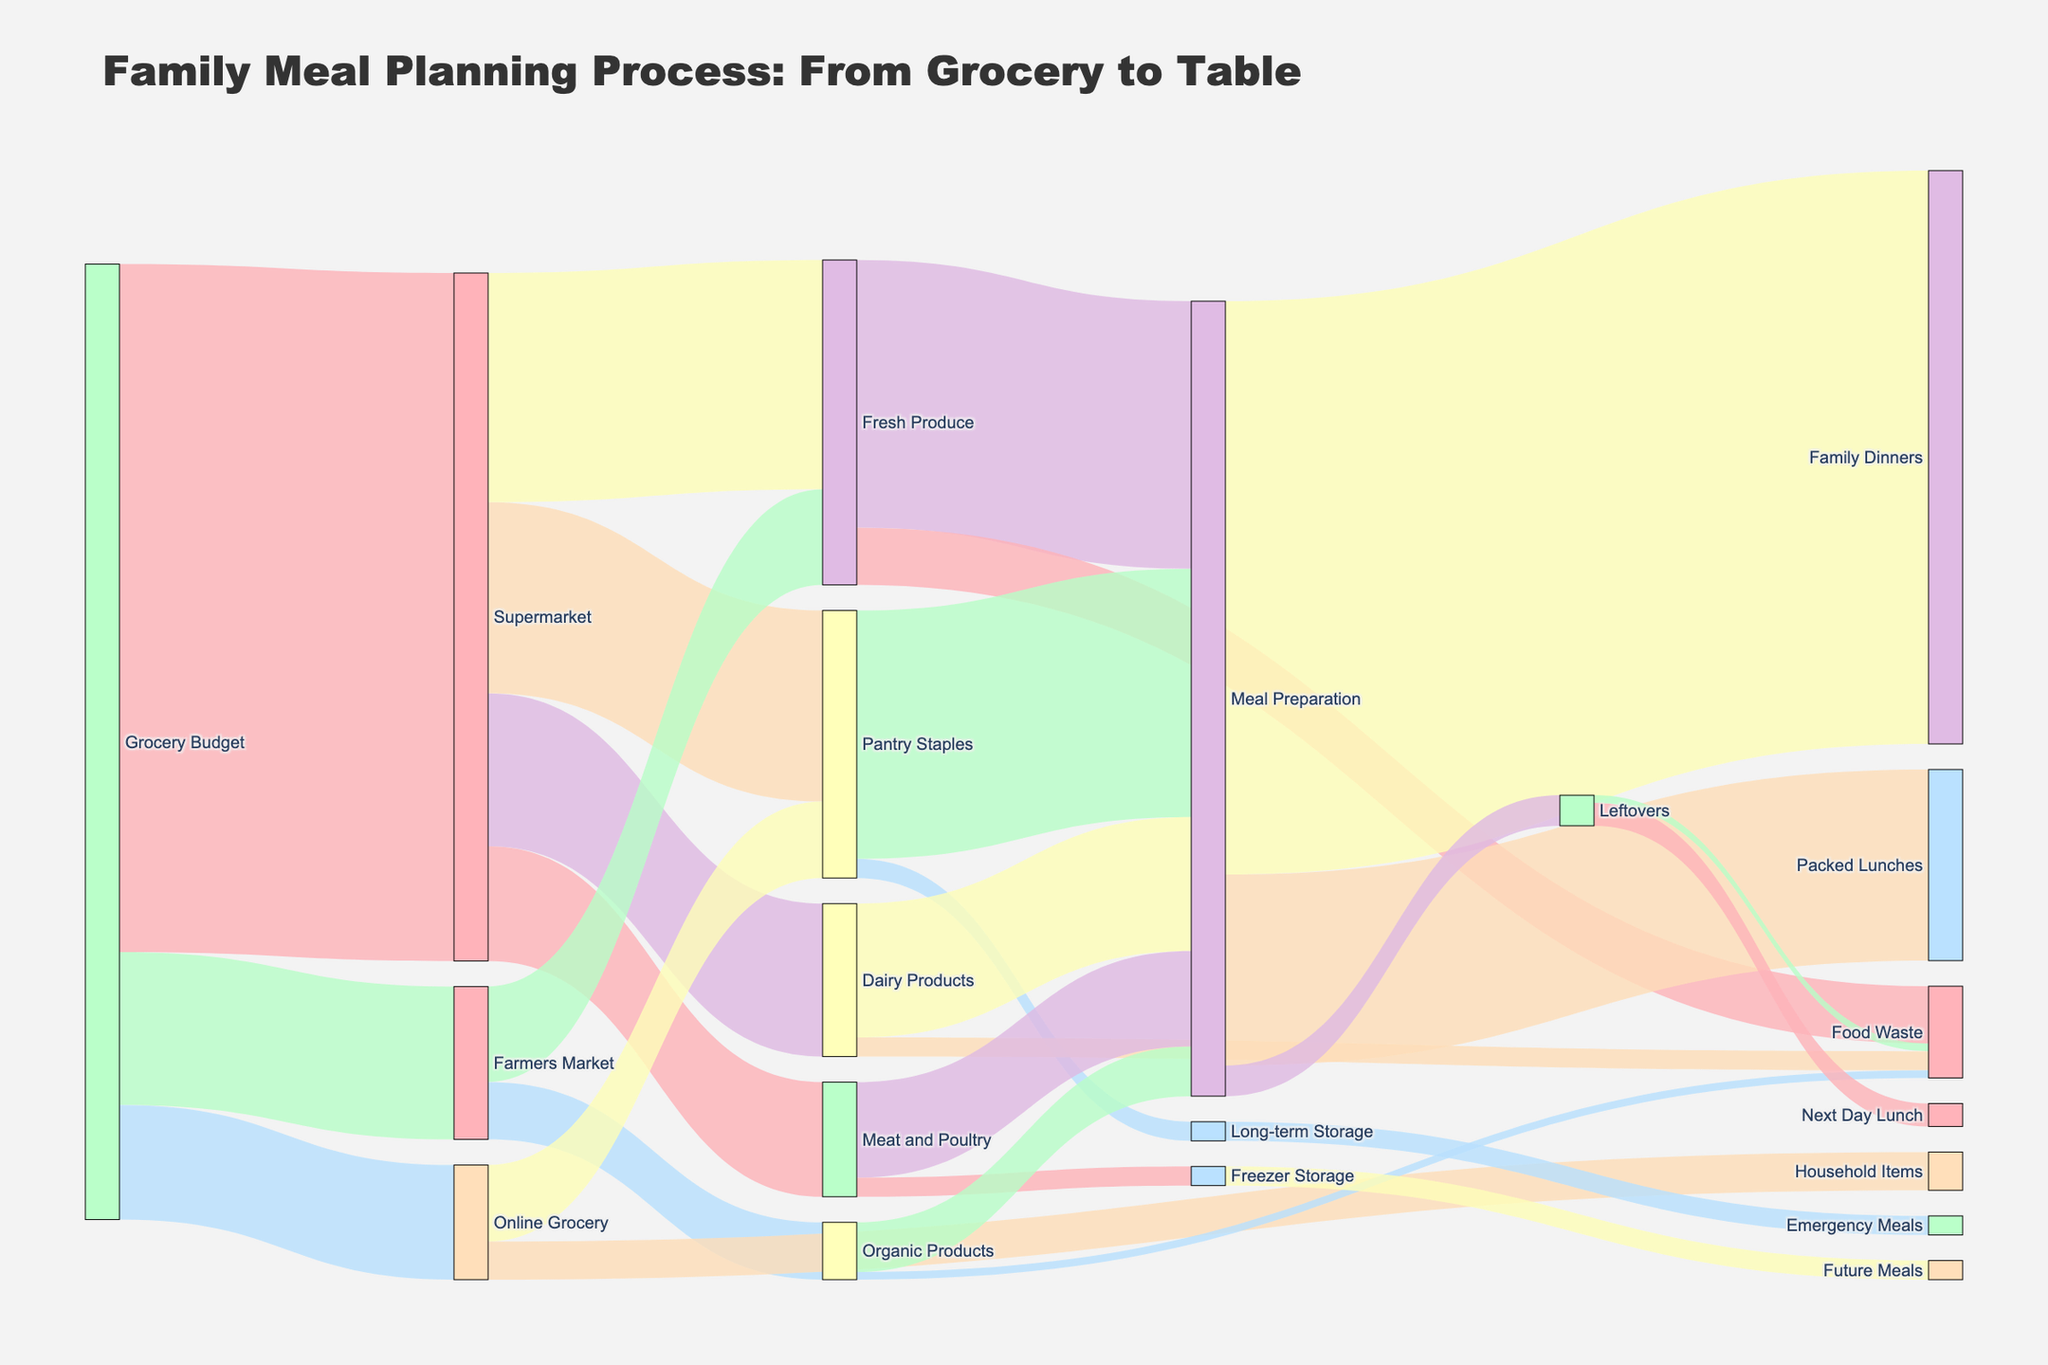What's the largest portion of the grocery budget allocated to? The figure shows the breakdown of the grocery budget into different categories. The largest flow from "Grocery Budget" is towards the "Supermarket", which amounts to 180 units.
Answer: Supermarket How much is spent on Dairy Products and Meat and Poultry combined from the Supermarket? First, identify the amount allocated to each from the Supermarket: Dairy Products (40) and Meat and Poultry (30). Summing them up gives 40 + 30 = 70.
Answer: 70 What portion of Fresh Produce from the Supermarket goes into Meal Preparation? The flow from Fresh Produce (Supermarket) to Meal Preparation is 60 units. This can be seen by following the flows from Fresh Produce to their next destination.
Answer: 60 Which is higher, the amount of Fresh Produce obtained from the Supermarket or the Farmers Market? Compare the two flows: Fresh Produce from Supermarket (60) and from Farmers Market (25). The Supermarket provides a higher amount.
Answer: Supermarket How much of the Pantry Staples sourced from the Supermarket goes to Meal Preparation? Observe the flow from Pantry Staples (Supermarket) to Meal Preparation, which is 65 units.
Answer: 65 What is the total Food Waste generated from Fresh Produce, Dairy Products, and Organic Products? Sum the Food Waste amounts from Fresh Produce (15), Dairy Products (5), and Organic Products (2). This gives 15 + 5 + 2 = 22.
Answer: 22 After meal preparation, how many units are allocated to Family Dinners, Packed Lunches, and Leftovers? The flows from Meal Preparation are: Family Dinners (150), Packed Lunches (50), and Leftovers (8). Adding them gives 150 + 50 + 8 = 208.
Answer: 208 How much of the Leftovers are not wasted but used for the next day lunch? The flow from Leftovers to Next Day Lunch is 6 units. This is the amount not wasted.
Answer: 6 Which source has the least amount allocated for grocery and by how much? Compare the flows from Grocery Budget to three sources: Supermarket (180), Farmers Market (40), and Online Grocery (30). Online Grocery has the least amount. The difference with the next higher amount (Farmers Market) is 40 - 30 = 10.
Answer: Online Grocery, by 10 